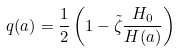Convert formula to latex. <formula><loc_0><loc_0><loc_500><loc_500>q ( a ) = \frac { 1 } { 2 } \left ( 1 - \tilde { \zeta } \frac { H _ { 0 } } { H ( a ) } \right )</formula> 